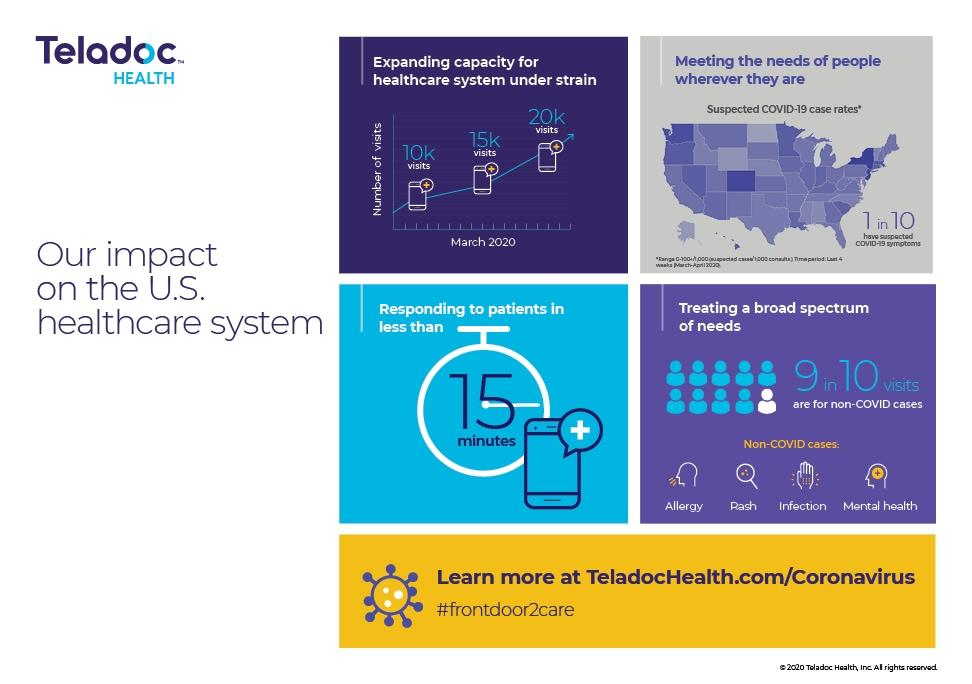Outline some significant characteristics in this image. In March, the total number of visits was 45,000. Out of 10 individuals, only 1 is not suspected of having COVID-19 symptoms. Out of 10 cases, 9 are not related to COVID-19. Out of 10, I have identified 1 instance of COVID-19. 